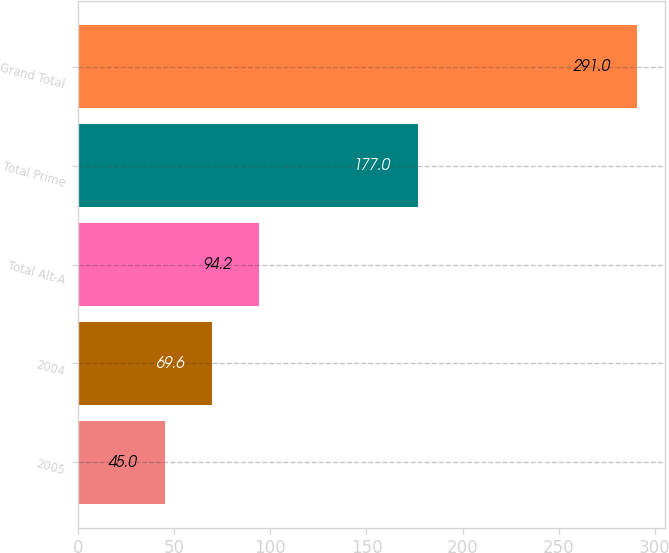<chart> <loc_0><loc_0><loc_500><loc_500><bar_chart><fcel>2005<fcel>2004<fcel>Total Alt-A<fcel>Total Prime<fcel>Grand Total<nl><fcel>45<fcel>69.6<fcel>94.2<fcel>177<fcel>291<nl></chart> 